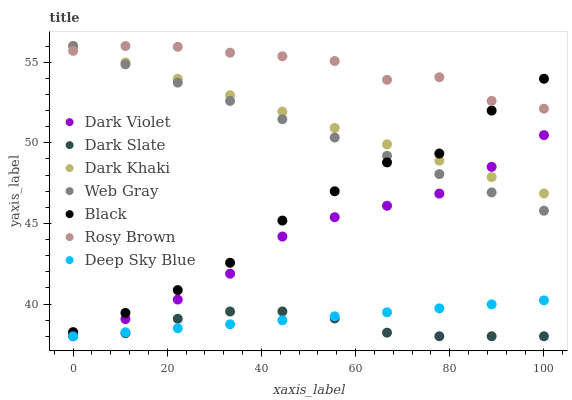Does Dark Slate have the minimum area under the curve?
Answer yes or no. Yes. Does Rosy Brown have the maximum area under the curve?
Answer yes or no. Yes. Does Dark Violet have the minimum area under the curve?
Answer yes or no. No. Does Dark Violet have the maximum area under the curve?
Answer yes or no. No. Is Deep Sky Blue the smoothest?
Answer yes or no. Yes. Is Black the roughest?
Answer yes or no. Yes. Is Rosy Brown the smoothest?
Answer yes or no. No. Is Rosy Brown the roughest?
Answer yes or no. No. Does Dark Slate have the lowest value?
Answer yes or no. Yes. Does Dark Violet have the lowest value?
Answer yes or no. No. Does Dark Khaki have the highest value?
Answer yes or no. Yes. Does Dark Violet have the highest value?
Answer yes or no. No. Is Dark Violet less than Black?
Answer yes or no. Yes. Is Black greater than Dark Violet?
Answer yes or no. Yes. Does Rosy Brown intersect Dark Khaki?
Answer yes or no. Yes. Is Rosy Brown less than Dark Khaki?
Answer yes or no. No. Is Rosy Brown greater than Dark Khaki?
Answer yes or no. No. Does Dark Violet intersect Black?
Answer yes or no. No. 